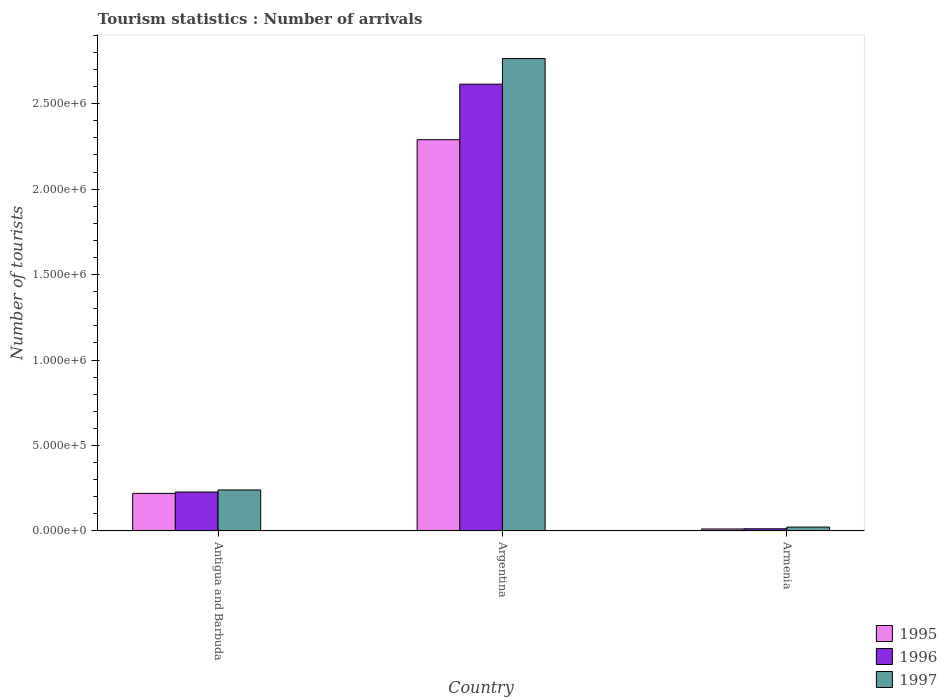How many different coloured bars are there?
Provide a short and direct response. 3. Are the number of bars per tick equal to the number of legend labels?
Offer a very short reply. Yes. Are the number of bars on each tick of the X-axis equal?
Ensure brevity in your answer.  Yes. How many bars are there on the 3rd tick from the right?
Provide a short and direct response. 3. What is the number of tourist arrivals in 1996 in Armenia?
Your answer should be very brief. 1.30e+04. Across all countries, what is the maximum number of tourist arrivals in 1995?
Give a very brief answer. 2.29e+06. Across all countries, what is the minimum number of tourist arrivals in 1997?
Ensure brevity in your answer.  2.30e+04. In which country was the number of tourist arrivals in 1995 maximum?
Provide a succinct answer. Argentina. In which country was the number of tourist arrivals in 1996 minimum?
Offer a terse response. Armenia. What is the total number of tourist arrivals in 1995 in the graph?
Your answer should be compact. 2.52e+06. What is the difference between the number of tourist arrivals in 1997 in Antigua and Barbuda and that in Argentina?
Your answer should be very brief. -2.52e+06. What is the difference between the number of tourist arrivals in 1997 in Armenia and the number of tourist arrivals in 1996 in Antigua and Barbuda?
Ensure brevity in your answer.  -2.05e+05. What is the average number of tourist arrivals in 1997 per country?
Your answer should be compact. 1.01e+06. What is the difference between the number of tourist arrivals of/in 1996 and number of tourist arrivals of/in 1995 in Antigua and Barbuda?
Provide a succinct answer. 8000. In how many countries, is the number of tourist arrivals in 1995 greater than 1500000?
Make the answer very short. 1. What is the ratio of the number of tourist arrivals in 1997 in Argentina to that in Armenia?
Offer a very short reply. 120.17. What is the difference between the highest and the second highest number of tourist arrivals in 1995?
Provide a short and direct response. 2.07e+06. What is the difference between the highest and the lowest number of tourist arrivals in 1995?
Give a very brief answer. 2.28e+06. Is the sum of the number of tourist arrivals in 1996 in Argentina and Armenia greater than the maximum number of tourist arrivals in 1995 across all countries?
Offer a very short reply. Yes. What does the 2nd bar from the right in Antigua and Barbuda represents?
Offer a very short reply. 1996. How many bars are there?
Offer a terse response. 9. How many countries are there in the graph?
Your answer should be compact. 3. Does the graph contain any zero values?
Give a very brief answer. No. Does the graph contain grids?
Keep it short and to the point. No. Where does the legend appear in the graph?
Your answer should be very brief. Bottom right. What is the title of the graph?
Your answer should be compact. Tourism statistics : Number of arrivals. Does "1996" appear as one of the legend labels in the graph?
Ensure brevity in your answer.  Yes. What is the label or title of the X-axis?
Your response must be concise. Country. What is the label or title of the Y-axis?
Your answer should be very brief. Number of tourists. What is the Number of tourists in 1996 in Antigua and Barbuda?
Your answer should be very brief. 2.28e+05. What is the Number of tourists of 1995 in Argentina?
Your answer should be compact. 2.29e+06. What is the Number of tourists in 1996 in Argentina?
Your response must be concise. 2.61e+06. What is the Number of tourists in 1997 in Argentina?
Offer a terse response. 2.76e+06. What is the Number of tourists of 1995 in Armenia?
Your response must be concise. 1.20e+04. What is the Number of tourists in 1996 in Armenia?
Your answer should be very brief. 1.30e+04. What is the Number of tourists of 1997 in Armenia?
Make the answer very short. 2.30e+04. Across all countries, what is the maximum Number of tourists of 1995?
Your answer should be compact. 2.29e+06. Across all countries, what is the maximum Number of tourists in 1996?
Your answer should be compact. 2.61e+06. Across all countries, what is the maximum Number of tourists in 1997?
Keep it short and to the point. 2.76e+06. Across all countries, what is the minimum Number of tourists in 1995?
Your response must be concise. 1.20e+04. Across all countries, what is the minimum Number of tourists in 1996?
Your answer should be compact. 1.30e+04. Across all countries, what is the minimum Number of tourists of 1997?
Your answer should be compact. 2.30e+04. What is the total Number of tourists of 1995 in the graph?
Ensure brevity in your answer.  2.52e+06. What is the total Number of tourists of 1996 in the graph?
Your answer should be compact. 2.86e+06. What is the total Number of tourists of 1997 in the graph?
Your answer should be compact. 3.03e+06. What is the difference between the Number of tourists in 1995 in Antigua and Barbuda and that in Argentina?
Make the answer very short. -2.07e+06. What is the difference between the Number of tourists in 1996 in Antigua and Barbuda and that in Argentina?
Your response must be concise. -2.39e+06. What is the difference between the Number of tourists of 1997 in Antigua and Barbuda and that in Argentina?
Give a very brief answer. -2.52e+06. What is the difference between the Number of tourists in 1995 in Antigua and Barbuda and that in Armenia?
Offer a very short reply. 2.08e+05. What is the difference between the Number of tourists in 1996 in Antigua and Barbuda and that in Armenia?
Offer a terse response. 2.15e+05. What is the difference between the Number of tourists of 1997 in Antigua and Barbuda and that in Armenia?
Your answer should be compact. 2.17e+05. What is the difference between the Number of tourists in 1995 in Argentina and that in Armenia?
Make the answer very short. 2.28e+06. What is the difference between the Number of tourists of 1996 in Argentina and that in Armenia?
Make the answer very short. 2.60e+06. What is the difference between the Number of tourists in 1997 in Argentina and that in Armenia?
Keep it short and to the point. 2.74e+06. What is the difference between the Number of tourists in 1995 in Antigua and Barbuda and the Number of tourists in 1996 in Argentina?
Give a very brief answer. -2.39e+06. What is the difference between the Number of tourists of 1995 in Antigua and Barbuda and the Number of tourists of 1997 in Argentina?
Keep it short and to the point. -2.54e+06. What is the difference between the Number of tourists of 1996 in Antigua and Barbuda and the Number of tourists of 1997 in Argentina?
Offer a very short reply. -2.54e+06. What is the difference between the Number of tourists of 1995 in Antigua and Barbuda and the Number of tourists of 1996 in Armenia?
Offer a very short reply. 2.07e+05. What is the difference between the Number of tourists of 1995 in Antigua and Barbuda and the Number of tourists of 1997 in Armenia?
Offer a very short reply. 1.97e+05. What is the difference between the Number of tourists in 1996 in Antigua and Barbuda and the Number of tourists in 1997 in Armenia?
Your response must be concise. 2.05e+05. What is the difference between the Number of tourists in 1995 in Argentina and the Number of tourists in 1996 in Armenia?
Your answer should be compact. 2.28e+06. What is the difference between the Number of tourists in 1995 in Argentina and the Number of tourists in 1997 in Armenia?
Make the answer very short. 2.27e+06. What is the difference between the Number of tourists in 1996 in Argentina and the Number of tourists in 1997 in Armenia?
Your answer should be very brief. 2.59e+06. What is the average Number of tourists of 1995 per country?
Give a very brief answer. 8.40e+05. What is the average Number of tourists of 1996 per country?
Provide a short and direct response. 9.52e+05. What is the average Number of tourists in 1997 per country?
Provide a short and direct response. 1.01e+06. What is the difference between the Number of tourists of 1995 and Number of tourists of 1996 in Antigua and Barbuda?
Ensure brevity in your answer.  -8000. What is the difference between the Number of tourists of 1995 and Number of tourists of 1997 in Antigua and Barbuda?
Provide a short and direct response. -2.00e+04. What is the difference between the Number of tourists of 1996 and Number of tourists of 1997 in Antigua and Barbuda?
Provide a short and direct response. -1.20e+04. What is the difference between the Number of tourists in 1995 and Number of tourists in 1996 in Argentina?
Give a very brief answer. -3.25e+05. What is the difference between the Number of tourists of 1995 and Number of tourists of 1997 in Argentina?
Your answer should be very brief. -4.75e+05. What is the difference between the Number of tourists in 1995 and Number of tourists in 1996 in Armenia?
Provide a succinct answer. -1000. What is the difference between the Number of tourists of 1995 and Number of tourists of 1997 in Armenia?
Offer a very short reply. -1.10e+04. What is the difference between the Number of tourists in 1996 and Number of tourists in 1997 in Armenia?
Give a very brief answer. -10000. What is the ratio of the Number of tourists in 1995 in Antigua and Barbuda to that in Argentina?
Offer a terse response. 0.1. What is the ratio of the Number of tourists in 1996 in Antigua and Barbuda to that in Argentina?
Make the answer very short. 0.09. What is the ratio of the Number of tourists in 1997 in Antigua and Barbuda to that in Argentina?
Offer a terse response. 0.09. What is the ratio of the Number of tourists in 1995 in Antigua and Barbuda to that in Armenia?
Provide a succinct answer. 18.33. What is the ratio of the Number of tourists of 1996 in Antigua and Barbuda to that in Armenia?
Keep it short and to the point. 17.54. What is the ratio of the Number of tourists of 1997 in Antigua and Barbuda to that in Armenia?
Your answer should be very brief. 10.43. What is the ratio of the Number of tourists of 1995 in Argentina to that in Armenia?
Your answer should be very brief. 190.75. What is the ratio of the Number of tourists of 1996 in Argentina to that in Armenia?
Your answer should be very brief. 201.08. What is the ratio of the Number of tourists in 1997 in Argentina to that in Armenia?
Give a very brief answer. 120.17. What is the difference between the highest and the second highest Number of tourists in 1995?
Your response must be concise. 2.07e+06. What is the difference between the highest and the second highest Number of tourists of 1996?
Your answer should be compact. 2.39e+06. What is the difference between the highest and the second highest Number of tourists of 1997?
Your answer should be very brief. 2.52e+06. What is the difference between the highest and the lowest Number of tourists in 1995?
Your answer should be very brief. 2.28e+06. What is the difference between the highest and the lowest Number of tourists of 1996?
Your response must be concise. 2.60e+06. What is the difference between the highest and the lowest Number of tourists in 1997?
Provide a succinct answer. 2.74e+06. 